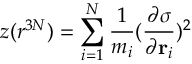<formula> <loc_0><loc_0><loc_500><loc_500>z ( r ^ { 3 N } ) = \sum _ { i = 1 } ^ { N } \frac { 1 } { m _ { i } } ( \frac { \partial \sigma } { \partial r _ { i } } ) ^ { 2 }</formula> 